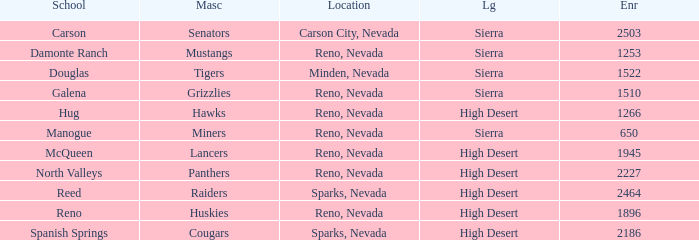Which leagues is the Galena school in? Sierra. 